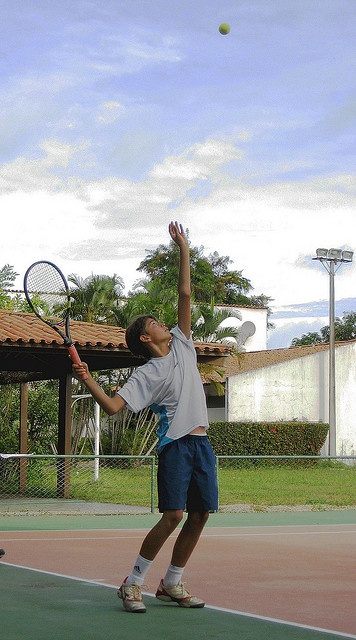Describe the objects in this image and their specific colors. I can see people in lavender, black, darkgray, and gray tones, tennis racket in lavender, lightgray, darkgray, gray, and black tones, and sports ball in lavender, olive, gray, darkgray, and darkgreen tones in this image. 